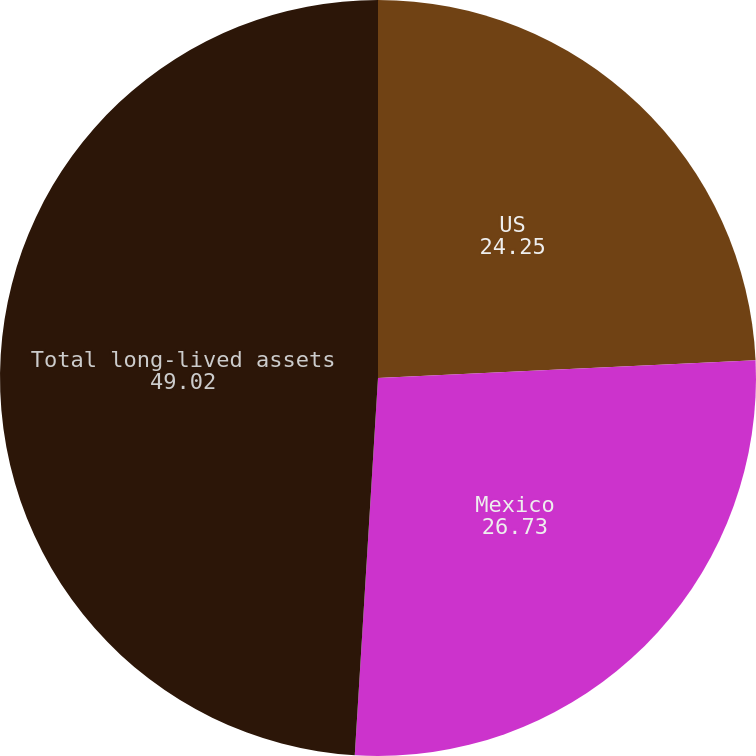<chart> <loc_0><loc_0><loc_500><loc_500><pie_chart><fcel>US<fcel>Mexico<fcel>Total long-lived assets<nl><fcel>24.25%<fcel>26.73%<fcel>49.02%<nl></chart> 